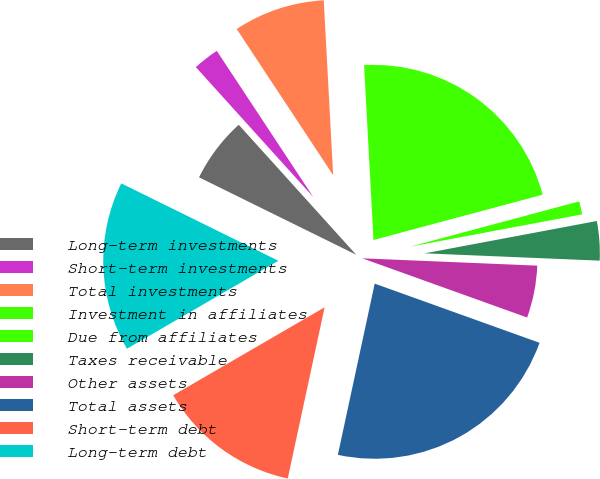Convert chart to OTSL. <chart><loc_0><loc_0><loc_500><loc_500><pie_chart><fcel>Long-term investments<fcel>Short-term investments<fcel>Total investments<fcel>Investment in affiliates<fcel>Due from affiliates<fcel>Taxes receivable<fcel>Other assets<fcel>Total assets<fcel>Short-term debt<fcel>Long-term debt<nl><fcel>6.02%<fcel>2.41%<fcel>8.43%<fcel>21.69%<fcel>1.21%<fcel>3.62%<fcel>4.82%<fcel>22.89%<fcel>13.25%<fcel>15.66%<nl></chart> 